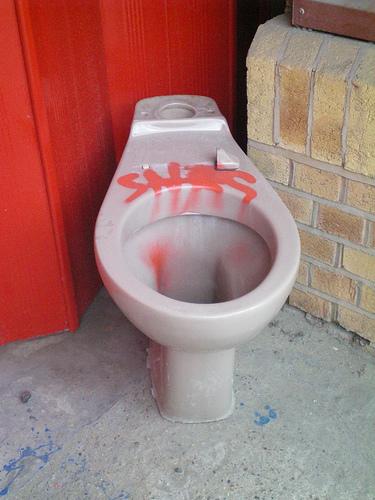What is required to make this functional?
Keep it brief. Water. Who wrote on the toilet?
Write a very short answer. Vandals. What happened to the toilet?
Answer briefly. Graffiti. 